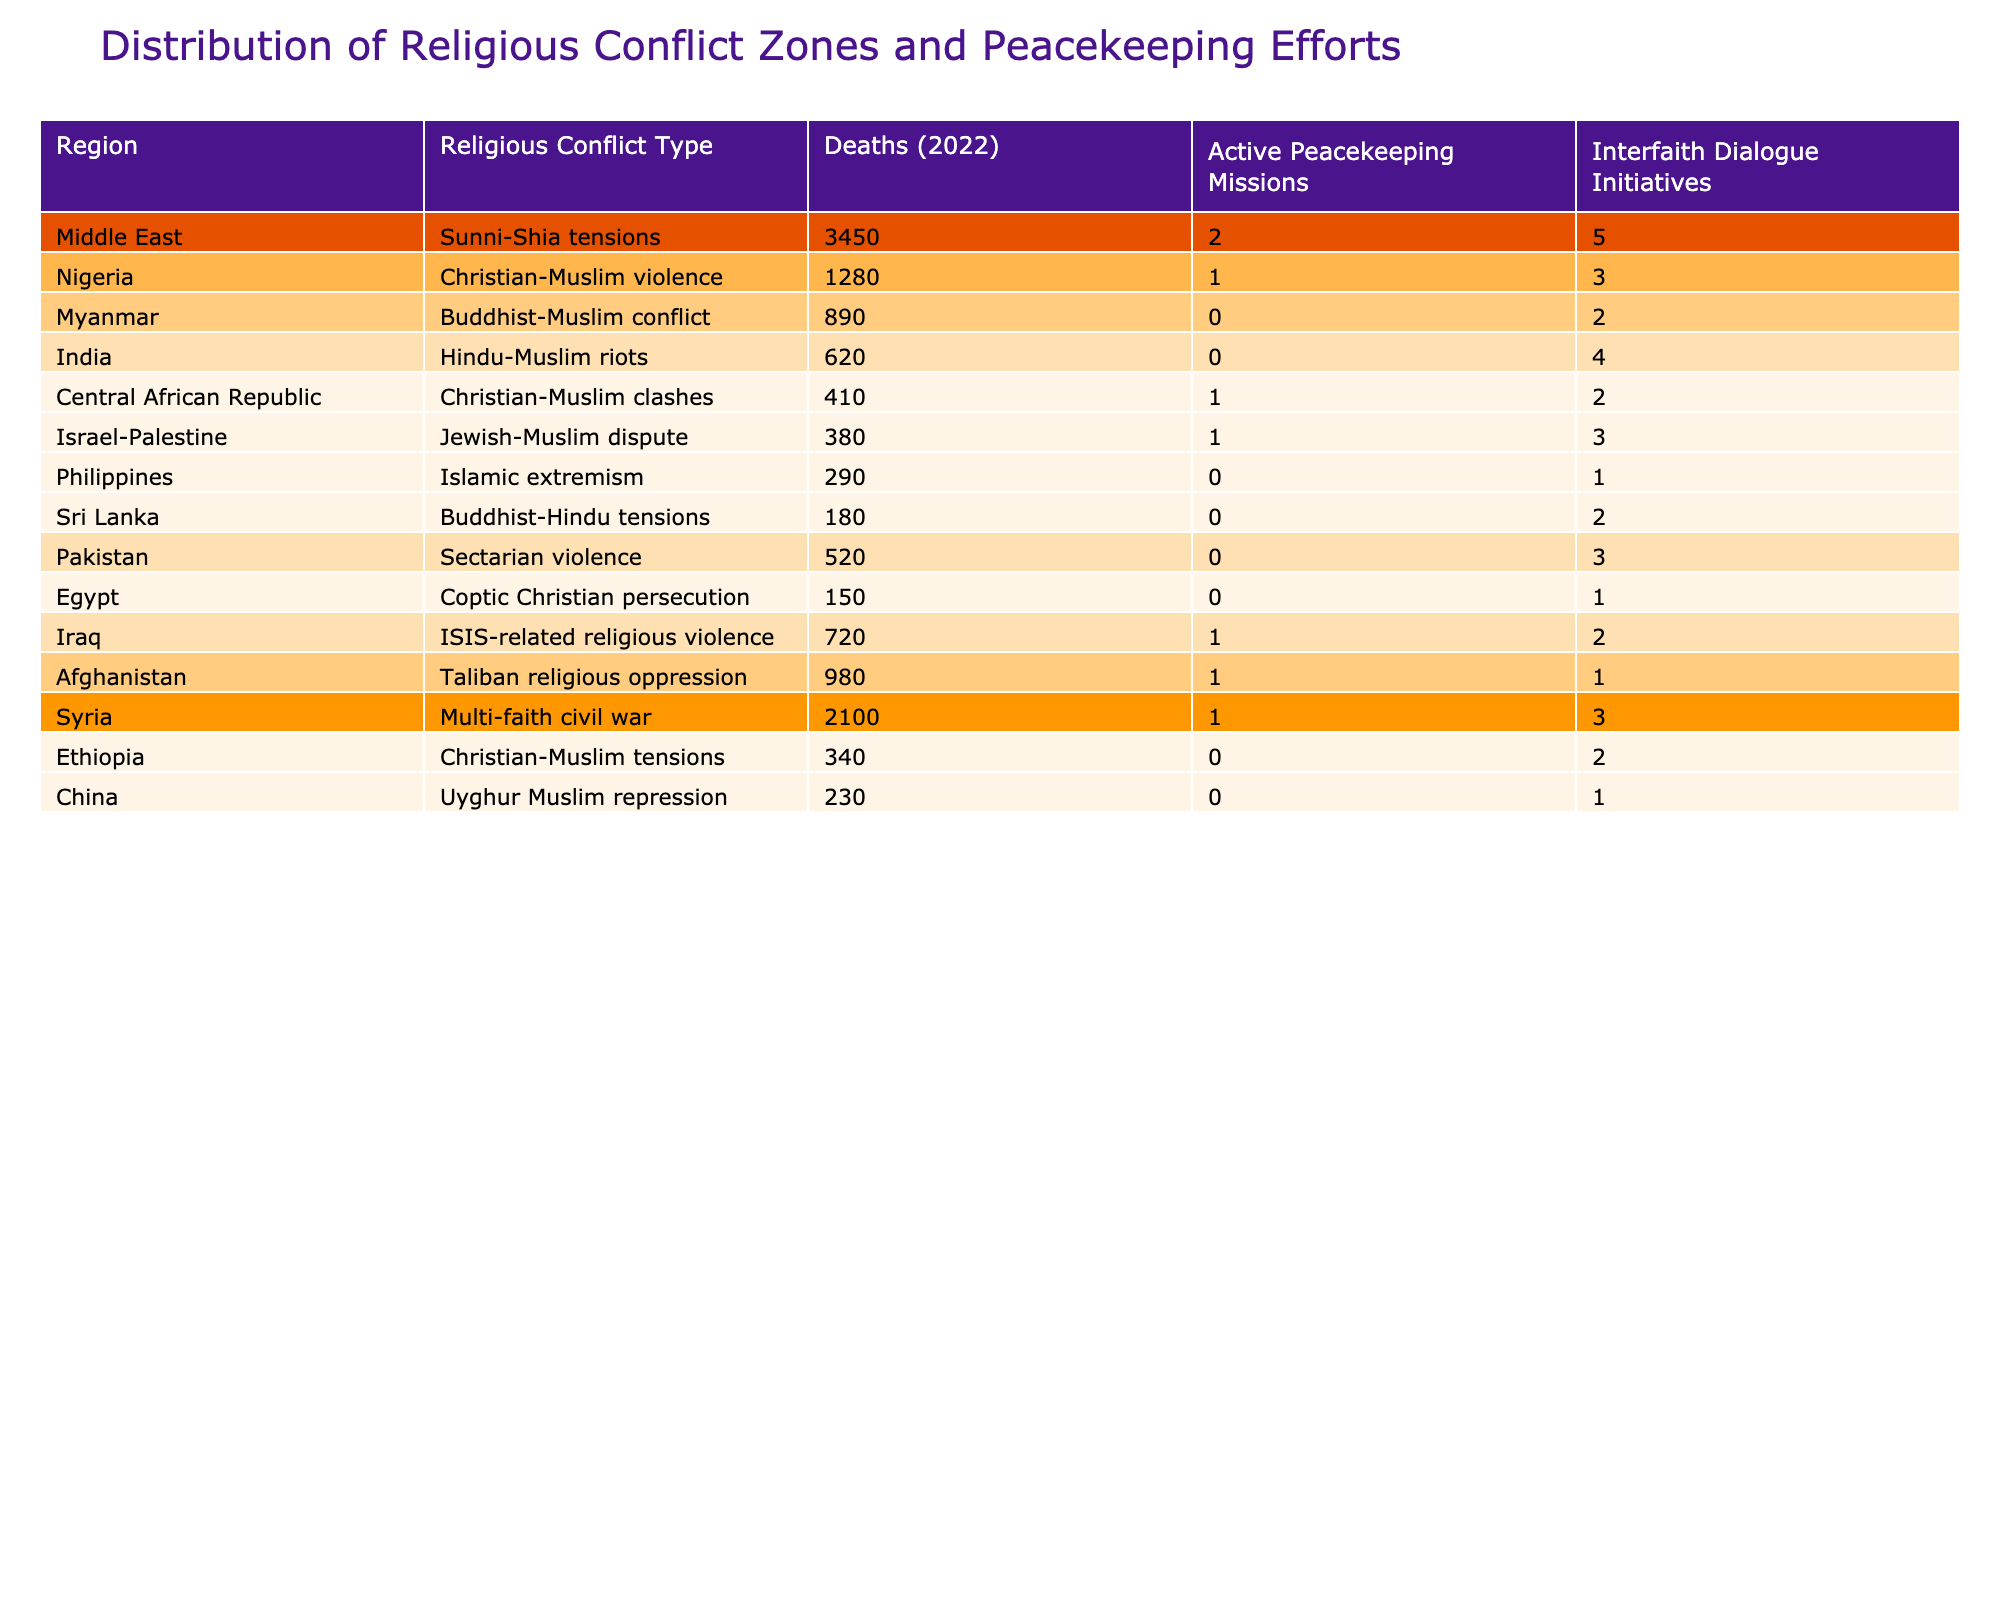What region has the highest number of deaths in religious conflicts in 2022? The region with the highest number of deaths is the Middle East, with 3450 deaths due to Sunni-Shia tensions.
Answer: Middle East How many active peacekeeping missions are there in Nigeria? Nigeria has 1 active peacekeeping mission in response to Christian-Muslim violence.
Answer: 1 Which conflict zone has the least number of deaths? The conflict zone with the least number of deaths is Egypt, with 150 deaths due to Coptic Christian persecution.
Answer: Egypt What is the total number of deaths in the Central African Republic and Iraq? The total number of deaths in the Central African Republic (410) and Iraq (720) is calculated as 410 + 720 = 1130.
Answer: 1130 Is there a peacekeeping mission in Myanmar? No, there are no active peacekeeping missions in Myanmar despite the Buddhist-Muslim conflict.
Answer: No Which two regions have interfaith dialogue initiatives of 2 or less? The regions with 2 or fewer interfaith dialogue initiatives are Myanmar (2) and Egypt (1).
Answer: Myanmar and Egypt What is the average number of deaths across all listed regions? To find the average, sum the deaths (3450 + 1280 + 890 + 620 + 410 + 380 + 290 + 180 + 520 + 150 + 720 + 980 + 2100 + 340 + 230) which equals 10190. Then, divide by the number of regions (15) to get the average: 10190 / 15 ≈ 679.33.
Answer: 679.33 Which religious conflict zone has the highest number of interfaith dialogue initiatives? The region with the highest number of interfaith dialogue initiatives is the Middle East, which has 5 initiatives.
Answer: Middle East How many regions have both peacekeeping missions and interfaith dialogue initiatives? There are 5 regions with both active peacekeeping missions and interfaith dialogue initiatives: Central African Republic, Israel-Palestine, Iraq, Afghanistan, and Syria.
Answer: 5 Which type of religious conflict has the highest number of deaths per peacekeeping mission? To find this, divide the number of deaths by the number of active peacekeeping missions for each conflict: Middle East (3450/2=1725), Nigeria (1280/1=1280), etc. The highest ratio is for the Middle East with 1725 deaths per mission.
Answer: Sunni-Shia tensions How many regions experience multi-faith conflicts, and is peacekeeping being implemented in all of them? There are two regions experiencing multi-faith conflicts: Syria and the Central African Republic. Both have active peacekeeping missions.
Answer: Yes 